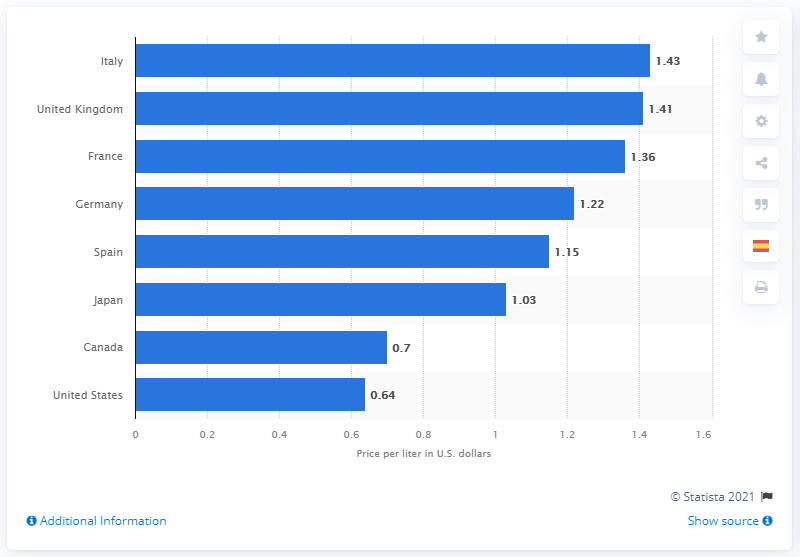List a handful of essential elements in this visual. The price per liter in the UK was 1.41 in June 2020. In June 2020, the average price per liter of diesel fuel in the United States was 0.64 dollars. 